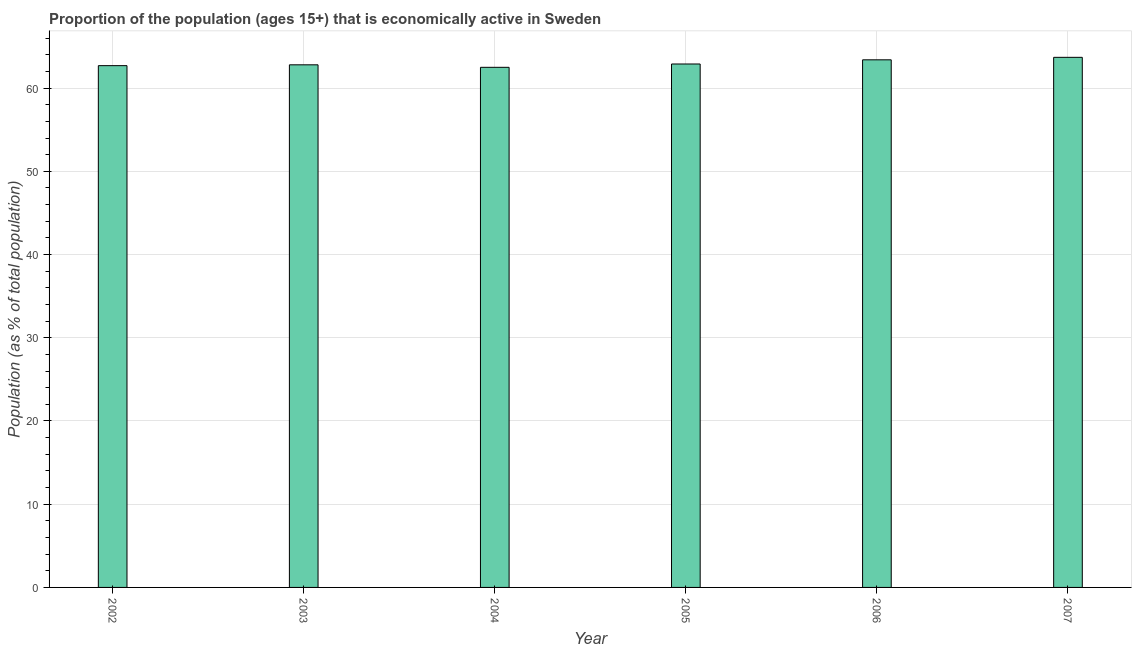Does the graph contain any zero values?
Provide a succinct answer. No. What is the title of the graph?
Give a very brief answer. Proportion of the population (ages 15+) that is economically active in Sweden. What is the label or title of the Y-axis?
Offer a very short reply. Population (as % of total population). What is the percentage of economically active population in 2003?
Offer a very short reply. 62.8. Across all years, what is the maximum percentage of economically active population?
Make the answer very short. 63.7. Across all years, what is the minimum percentage of economically active population?
Your response must be concise. 62.5. In which year was the percentage of economically active population maximum?
Offer a very short reply. 2007. What is the sum of the percentage of economically active population?
Your answer should be very brief. 378. What is the difference between the percentage of economically active population in 2002 and 2006?
Keep it short and to the point. -0.7. What is the median percentage of economically active population?
Make the answer very short. 62.85. Do a majority of the years between 2003 and 2007 (inclusive) have percentage of economically active population greater than 4 %?
Offer a terse response. Yes. What is the ratio of the percentage of economically active population in 2002 to that in 2004?
Provide a succinct answer. 1. Is the percentage of economically active population in 2002 less than that in 2004?
Your response must be concise. No. What is the difference between the highest and the second highest percentage of economically active population?
Your response must be concise. 0.3. Is the sum of the percentage of economically active population in 2003 and 2004 greater than the maximum percentage of economically active population across all years?
Your answer should be very brief. Yes. What is the difference between the highest and the lowest percentage of economically active population?
Make the answer very short. 1.2. In how many years, is the percentage of economically active population greater than the average percentage of economically active population taken over all years?
Your response must be concise. 2. How many years are there in the graph?
Offer a very short reply. 6. What is the Population (as % of total population) in 2002?
Keep it short and to the point. 62.7. What is the Population (as % of total population) in 2003?
Ensure brevity in your answer.  62.8. What is the Population (as % of total population) in 2004?
Provide a succinct answer. 62.5. What is the Population (as % of total population) of 2005?
Your answer should be very brief. 62.9. What is the Population (as % of total population) in 2006?
Offer a very short reply. 63.4. What is the Population (as % of total population) in 2007?
Keep it short and to the point. 63.7. What is the difference between the Population (as % of total population) in 2002 and 2003?
Provide a succinct answer. -0.1. What is the difference between the Population (as % of total population) in 2003 and 2004?
Your answer should be compact. 0.3. What is the difference between the Population (as % of total population) in 2003 and 2005?
Provide a short and direct response. -0.1. What is the difference between the Population (as % of total population) in 2003 and 2006?
Keep it short and to the point. -0.6. What is the difference between the Population (as % of total population) in 2003 and 2007?
Give a very brief answer. -0.9. What is the difference between the Population (as % of total population) in 2004 and 2005?
Ensure brevity in your answer.  -0.4. What is the difference between the Population (as % of total population) in 2004 and 2006?
Your answer should be compact. -0.9. What is the difference between the Population (as % of total population) in 2004 and 2007?
Provide a short and direct response. -1.2. What is the difference between the Population (as % of total population) in 2005 and 2006?
Offer a very short reply. -0.5. What is the difference between the Population (as % of total population) in 2005 and 2007?
Provide a succinct answer. -0.8. What is the ratio of the Population (as % of total population) in 2002 to that in 2005?
Provide a succinct answer. 1. What is the ratio of the Population (as % of total population) in 2002 to that in 2007?
Your answer should be compact. 0.98. What is the ratio of the Population (as % of total population) in 2004 to that in 2006?
Offer a very short reply. 0.99. What is the ratio of the Population (as % of total population) in 2004 to that in 2007?
Your answer should be compact. 0.98. What is the ratio of the Population (as % of total population) in 2005 to that in 2006?
Keep it short and to the point. 0.99. What is the ratio of the Population (as % of total population) in 2005 to that in 2007?
Keep it short and to the point. 0.99. 